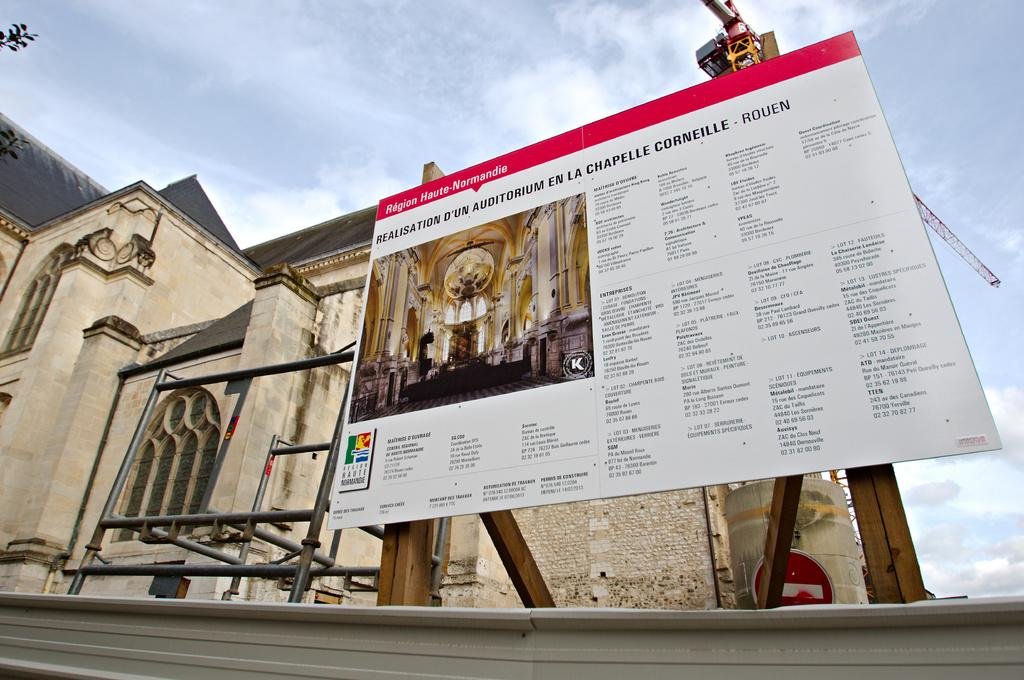<image>
Give a short and clear explanation of the subsequent image. Above a information sign are the words Region Haute-Normandie. 